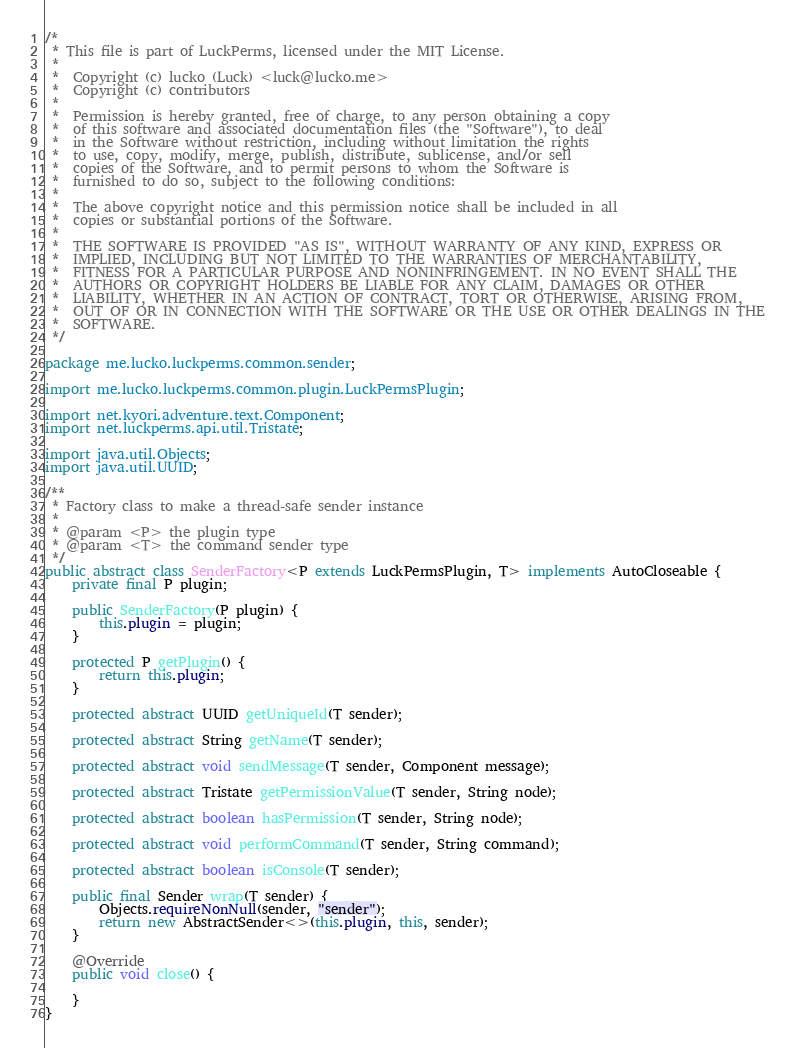Convert code to text. <code><loc_0><loc_0><loc_500><loc_500><_Java_>/*
 * This file is part of LuckPerms, licensed under the MIT License.
 *
 *  Copyright (c) lucko (Luck) <luck@lucko.me>
 *  Copyright (c) contributors
 *
 *  Permission is hereby granted, free of charge, to any person obtaining a copy
 *  of this software and associated documentation files (the "Software"), to deal
 *  in the Software without restriction, including without limitation the rights
 *  to use, copy, modify, merge, publish, distribute, sublicense, and/or sell
 *  copies of the Software, and to permit persons to whom the Software is
 *  furnished to do so, subject to the following conditions:
 *
 *  The above copyright notice and this permission notice shall be included in all
 *  copies or substantial portions of the Software.
 *
 *  THE SOFTWARE IS PROVIDED "AS IS", WITHOUT WARRANTY OF ANY KIND, EXPRESS OR
 *  IMPLIED, INCLUDING BUT NOT LIMITED TO THE WARRANTIES OF MERCHANTABILITY,
 *  FITNESS FOR A PARTICULAR PURPOSE AND NONINFRINGEMENT. IN NO EVENT SHALL THE
 *  AUTHORS OR COPYRIGHT HOLDERS BE LIABLE FOR ANY CLAIM, DAMAGES OR OTHER
 *  LIABILITY, WHETHER IN AN ACTION OF CONTRACT, TORT OR OTHERWISE, ARISING FROM,
 *  OUT OF OR IN CONNECTION WITH THE SOFTWARE OR THE USE OR OTHER DEALINGS IN THE
 *  SOFTWARE.
 */

package me.lucko.luckperms.common.sender;

import me.lucko.luckperms.common.plugin.LuckPermsPlugin;

import net.kyori.adventure.text.Component;
import net.luckperms.api.util.Tristate;

import java.util.Objects;
import java.util.UUID;

/**
 * Factory class to make a thread-safe sender instance
 *
 * @param <P> the plugin type
 * @param <T> the command sender type
 */
public abstract class SenderFactory<P extends LuckPermsPlugin, T> implements AutoCloseable {
    private final P plugin;

    public SenderFactory(P plugin) {
        this.plugin = plugin;
    }

    protected P getPlugin() {
        return this.plugin;
    }

    protected abstract UUID getUniqueId(T sender);

    protected abstract String getName(T sender);

    protected abstract void sendMessage(T sender, Component message);

    protected abstract Tristate getPermissionValue(T sender, String node);

    protected abstract boolean hasPermission(T sender, String node);

    protected abstract void performCommand(T sender, String command);

    protected abstract boolean isConsole(T sender);

    public final Sender wrap(T sender) {
        Objects.requireNonNull(sender, "sender");
        return new AbstractSender<>(this.plugin, this, sender);
    }

    @Override
    public void close() {

    }
}
</code> 